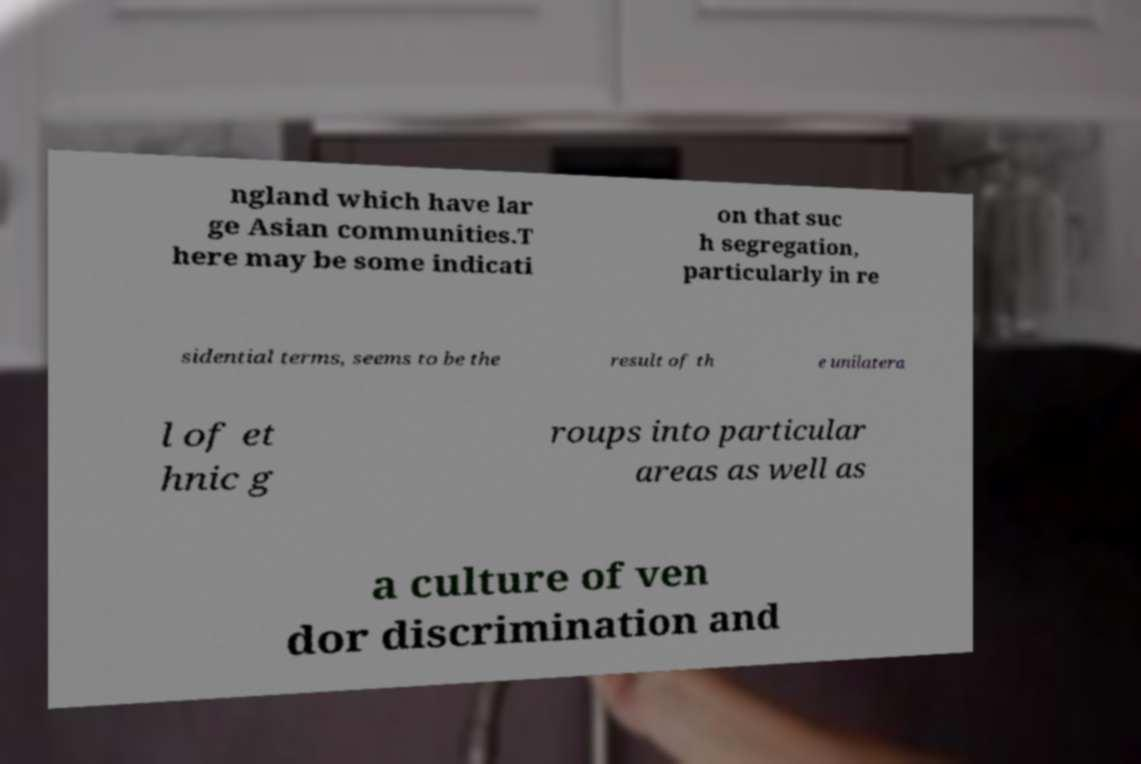Can you read and provide the text displayed in the image?This photo seems to have some interesting text. Can you extract and type it out for me? ngland which have lar ge Asian communities.T here may be some indicati on that suc h segregation, particularly in re sidential terms, seems to be the result of th e unilatera l of et hnic g roups into particular areas as well as a culture of ven dor discrimination and 